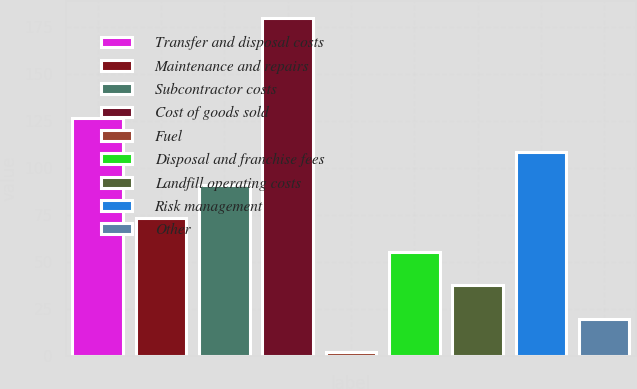Convert chart to OTSL. <chart><loc_0><loc_0><loc_500><loc_500><bar_chart><fcel>Transfer and disposal costs<fcel>Maintenance and repairs<fcel>Subcontractor costs<fcel>Cost of goods sold<fcel>Fuel<fcel>Disposal and franchise fees<fcel>Landfill operating costs<fcel>Risk management<fcel>Other<nl><fcel>126.6<fcel>73.2<fcel>91<fcel>180<fcel>2<fcel>55.4<fcel>37.6<fcel>108.8<fcel>19.8<nl></chart> 